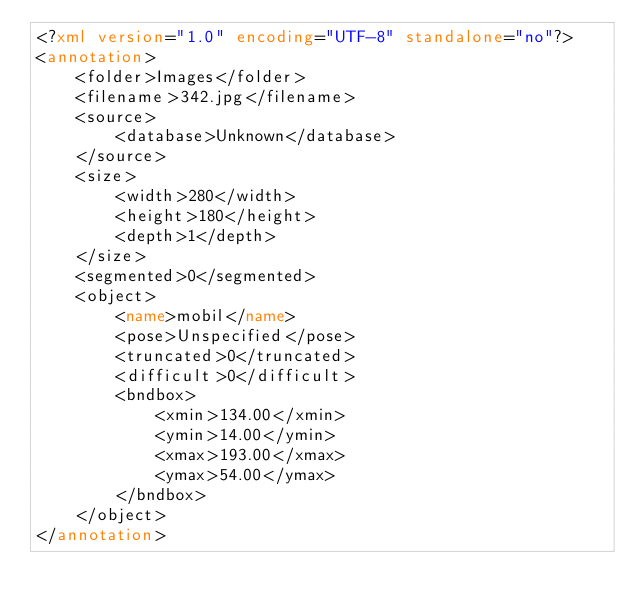<code> <loc_0><loc_0><loc_500><loc_500><_XML_><?xml version="1.0" encoding="UTF-8" standalone="no"?>
<annotation>
    <folder>Images</folder>
    <filename>342.jpg</filename>
    <source>
        <database>Unknown</database>
    </source>
    <size>
        <width>280</width>
        <height>180</height>
        <depth>1</depth>
    </size>
    <segmented>0</segmented>
    <object>
        <name>mobil</name>
        <pose>Unspecified</pose>
        <truncated>0</truncated>
        <difficult>0</difficult>
        <bndbox>
            <xmin>134.00</xmin>
            <ymin>14.00</ymin>
            <xmax>193.00</xmax>
            <ymax>54.00</ymax>
        </bndbox>
    </object>
</annotation>
</code> 